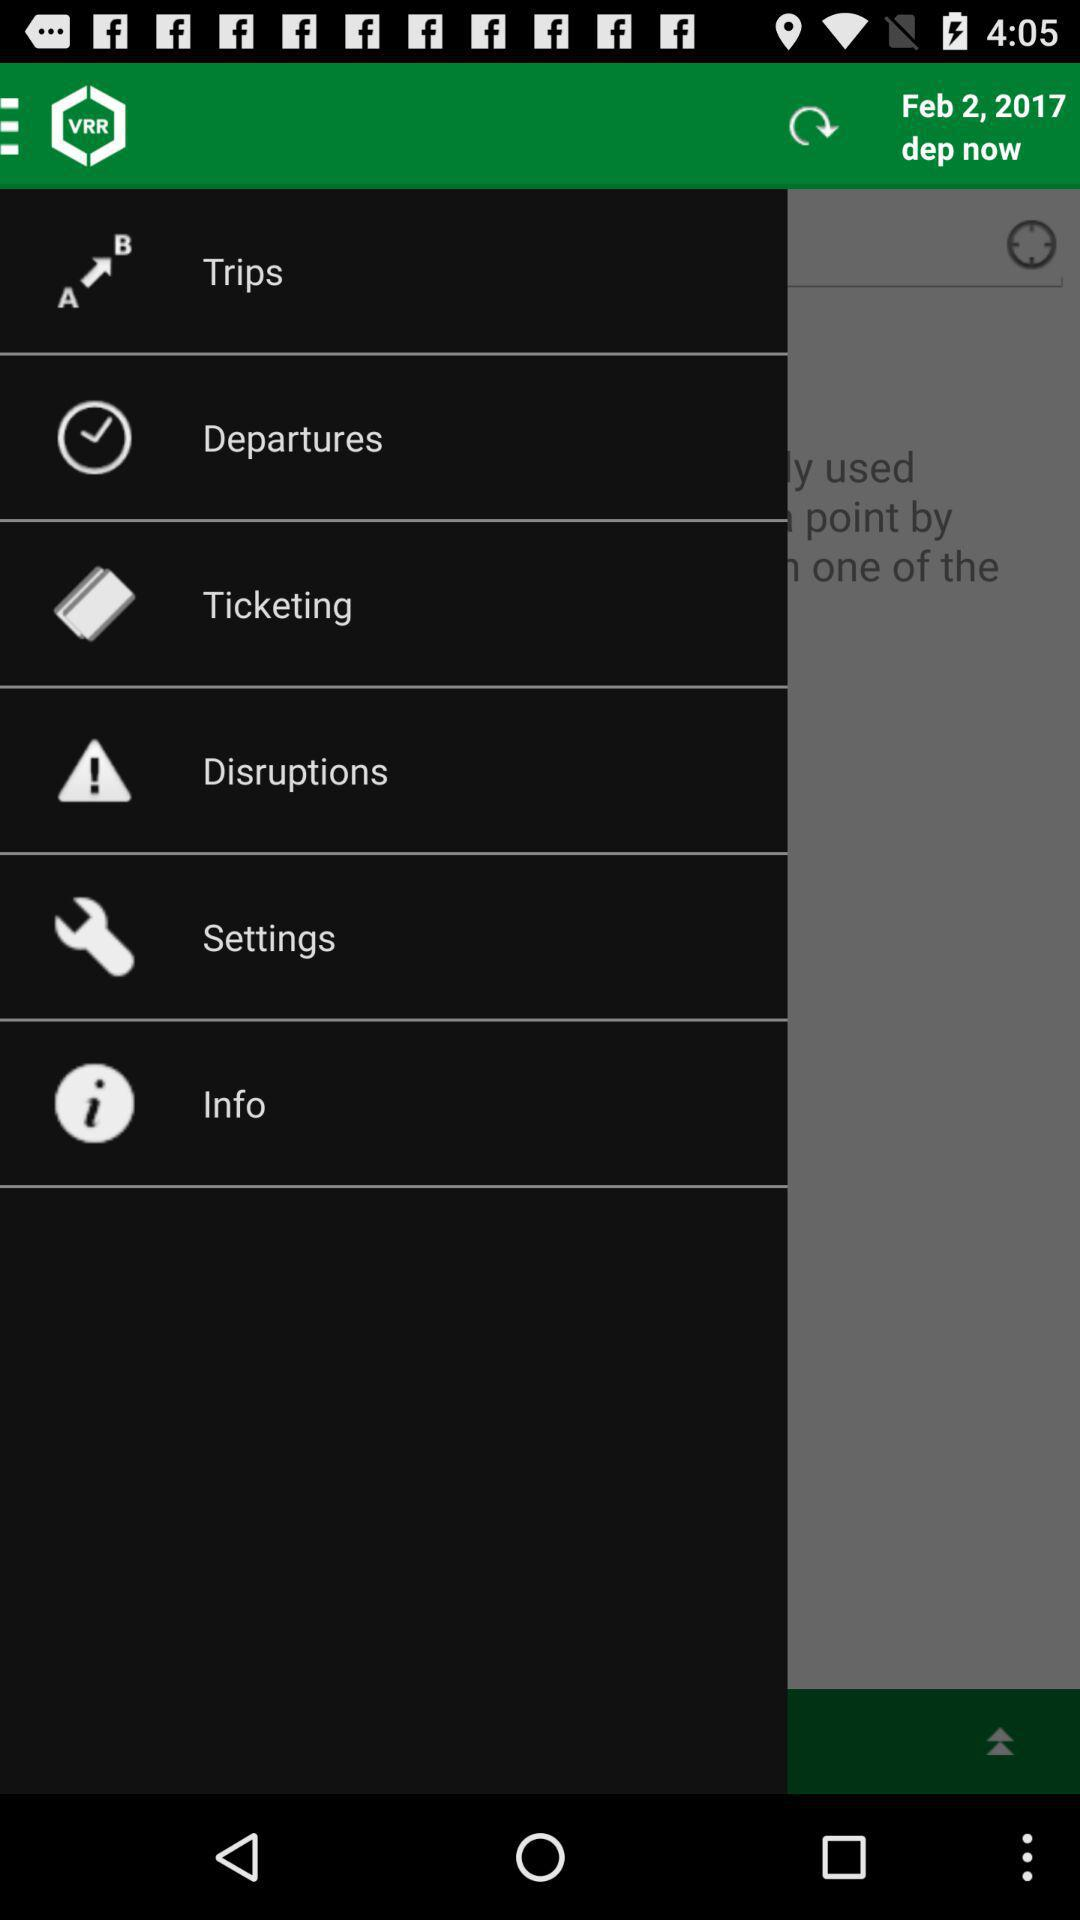On what date was the application last refreshed? The date was February 2, 2017. 